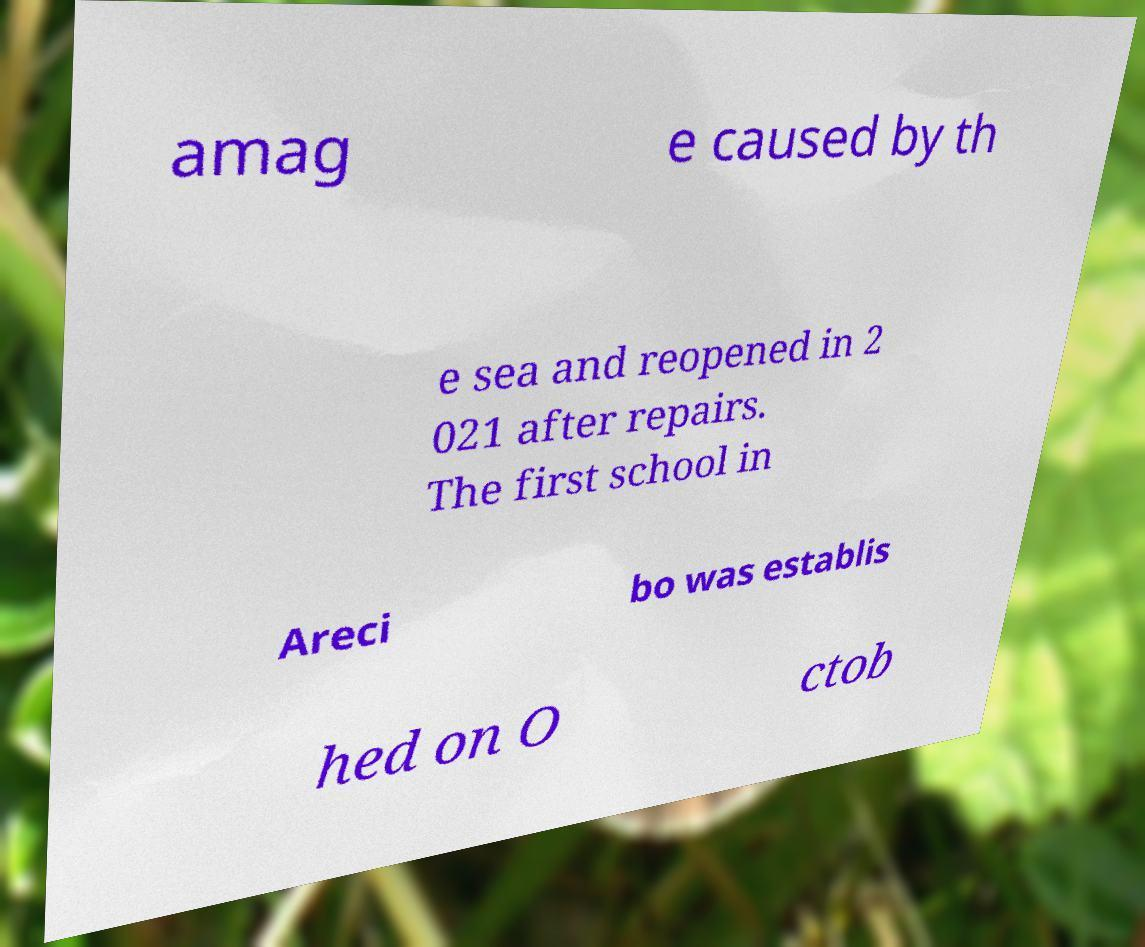Can you read and provide the text displayed in the image?This photo seems to have some interesting text. Can you extract and type it out for me? amag e caused by th e sea and reopened in 2 021 after repairs. The first school in Areci bo was establis hed on O ctob 